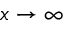Convert formula to latex. <formula><loc_0><loc_0><loc_500><loc_500>x \rightarrow \infty</formula> 